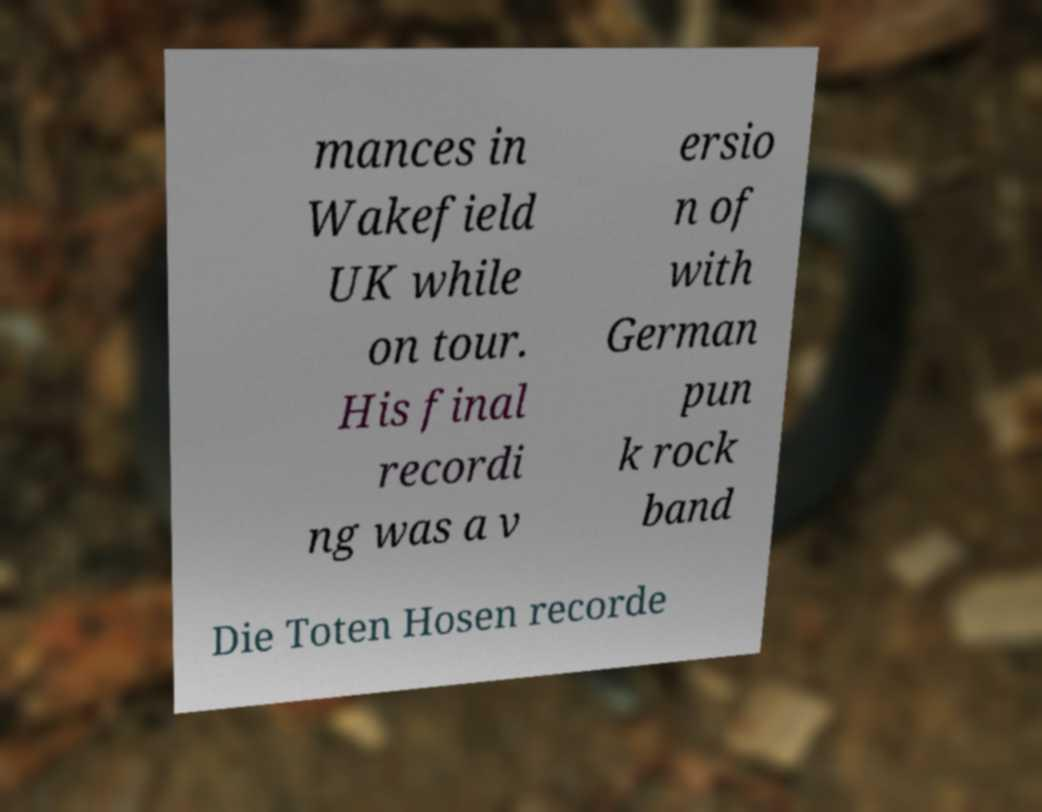What messages or text are displayed in this image? I need them in a readable, typed format. mances in Wakefield UK while on tour. His final recordi ng was a v ersio n of with German pun k rock band Die Toten Hosen recorde 